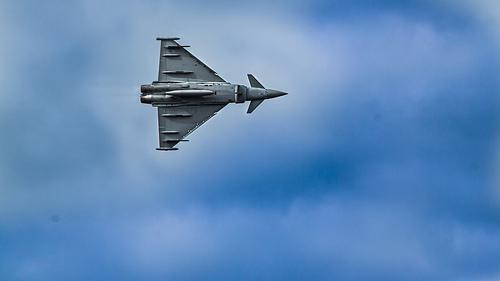Question: what is flying?
Choices:
A. Frisbee.
B. Kite.
C. Flag.
D. A plane.
Answer with the letter. Answer: D Question: what color are the clouds?
Choices:
A. White.
B. Blue.
C. Grey.
D. Black.
Answer with the letter. Answer: A Question: how many planes are there?
Choices:
A. 2.
B. 3.
C. 1.
D. 5.
Answer with the letter. Answer: C Question: what color is the plane?
Choices:
A. Gray.
B. Brown.
C. Green.
D. Blue.
Answer with the letter. Answer: A 